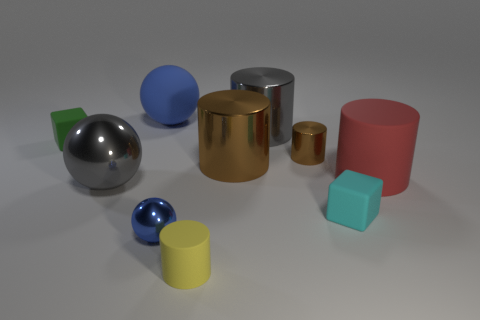Are there any red rubber cylinders on the left side of the tiny blue sphere? Upon inspection, there are no red rubber cylinders present on either side of the tiny blue sphere. 